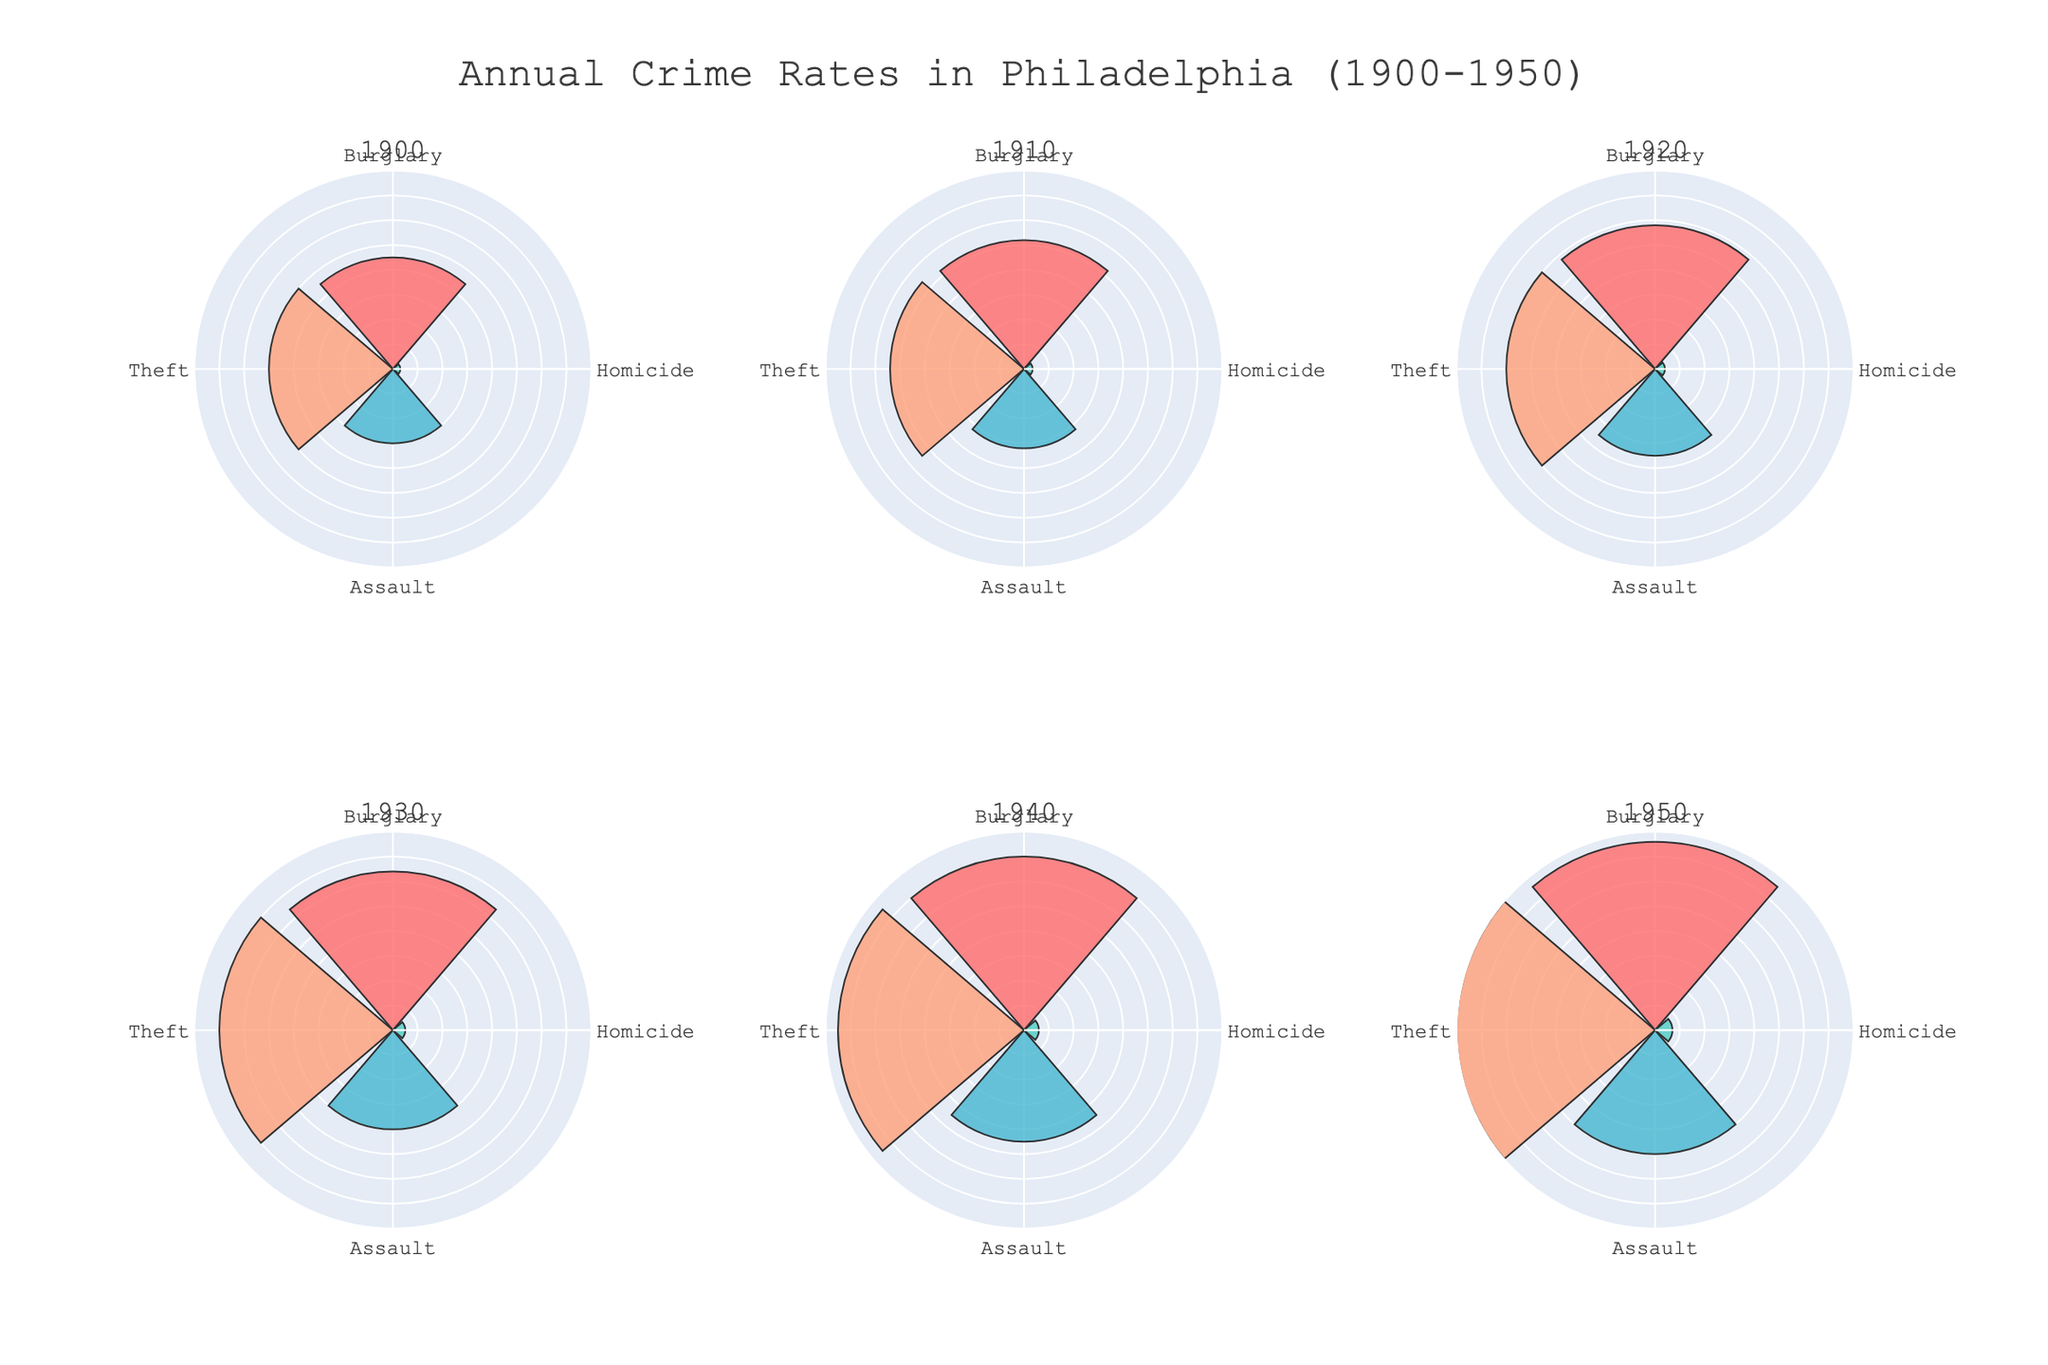What is the title of the figure? The title of the figure is usually displayed at the top and describes the overall content or purpose of the figure. Here, it's "Annual Crime Rates in Philadelphia (1900-1950)".
Answer: Annual Crime Rates in Philadelphia (1900-1950) Which year had the highest number of homicides? To answer this, locate the segment labeled "Homicide" in each subplot, then compare their radial lengths. The longest "Homicide" segment corresponds to the highest number of occurrences.
Answer: 1950 How did burglary rates change from 1900 to 1950? Compare the radial lengths of the Burglary segment in the subplots for 1900 and 1950. An increase in the length indicates a rise in crimes.
Answer: Increased In which year was the total number of crimes the highest? Sum the radial lengths of all crime types for each year and compare these sums. The year with the highest total sum has the most crimes.
Answer: 1950 How many more thefts were there in 1920 compared to 1900? Check the radial lengths of the Theft segment for the years 1920 and 1900. Subtract the number of occurrences in 1900 from that in 1920.
Answer: 100 Did the number of assaults increase or decrease from 1930 to 1940? Examine the radial lengths of the Assault segment for 1930 and 1940, observing whether the length increased or decreased.
Answer: Increased Which type of crime had the least occurrences in 1940? In the 1940 subplot, identify the segment with the smallest radial length. This crime type had the fewest occurrences.
Answer: Homicide What is the average number of burglaries from 1900 to 1950? Sum the occurrences of Burglary for each year provided (450, 520, 580, 640, 700, 760), then divide this sum by the number of years (6).
Answer: 608.33 Compare the theft rates of 1910 and 1930. Which year had fewer thefts? Check the radial lengths of the Theft segments for 1910 and 1930. The year with the shorter segment indicates fewer thefts.
Answer: 1910 Are there any years where all crime types increased compared to the previous decade? Check each subplot in sequence and compare the radial lengths of all crime types with those in the previous subplot to see if all increased.
Answer: Yes, 1940 compared to 1930 